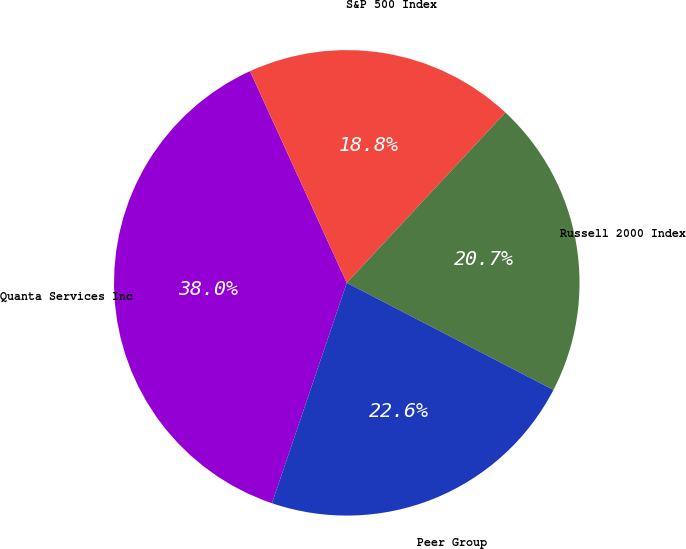Convert chart. <chart><loc_0><loc_0><loc_500><loc_500><pie_chart><fcel>Quanta Services Inc<fcel>S&P 500 Index<fcel>Russell 2000 Index<fcel>Peer Group<nl><fcel>37.97%<fcel>18.76%<fcel>20.68%<fcel>22.6%<nl></chart> 